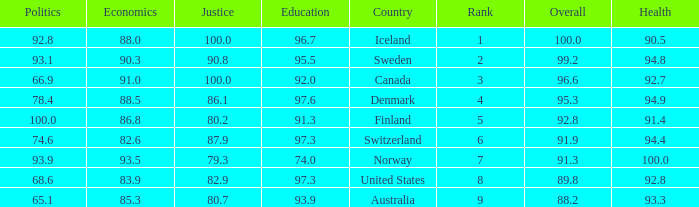What's the country with health being 91.4 Finland. 